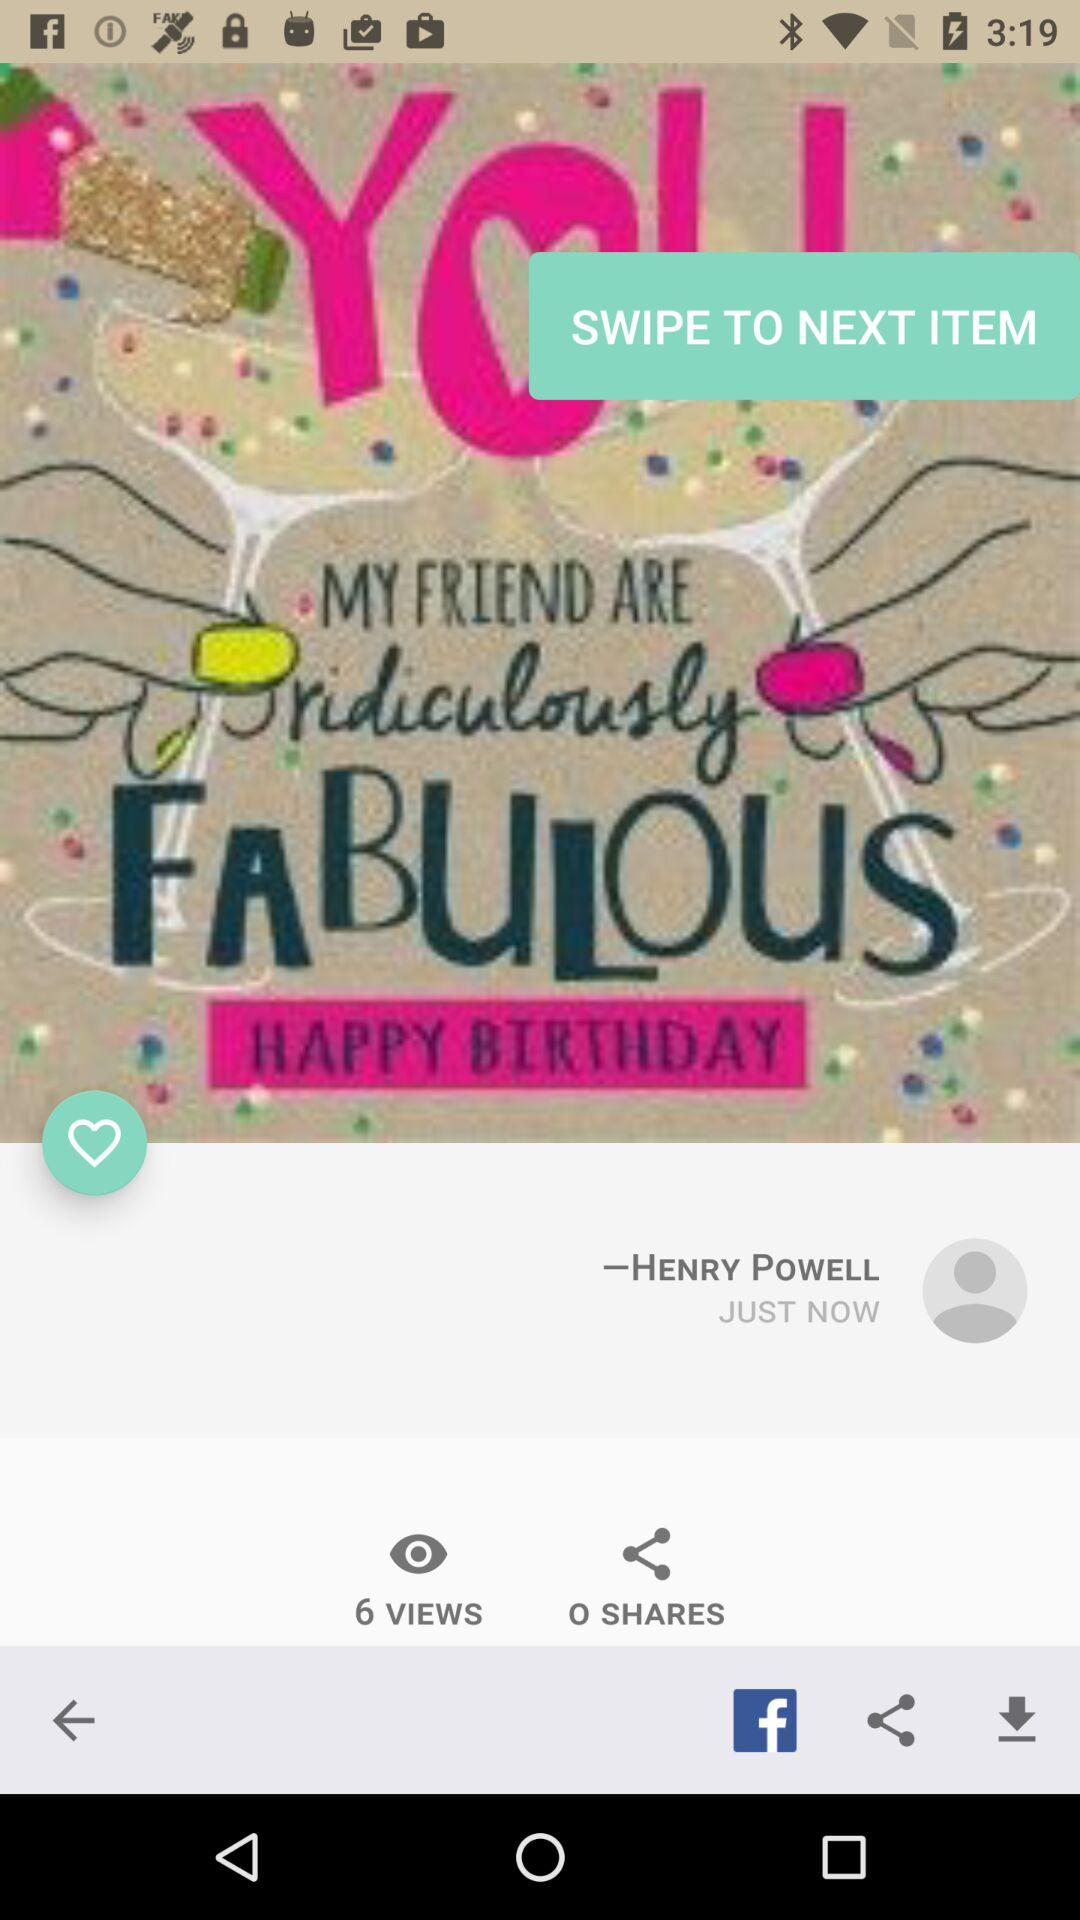Who posted the photo? The photo was posted by Henry Powell. 